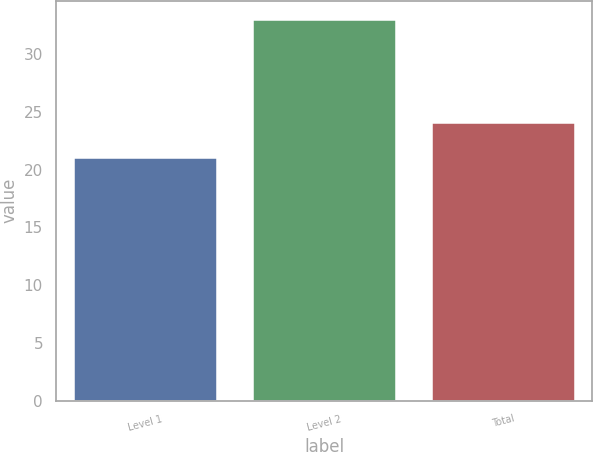<chart> <loc_0><loc_0><loc_500><loc_500><bar_chart><fcel>Level 1<fcel>Level 2<fcel>Total<nl><fcel>21<fcel>33<fcel>24<nl></chart> 